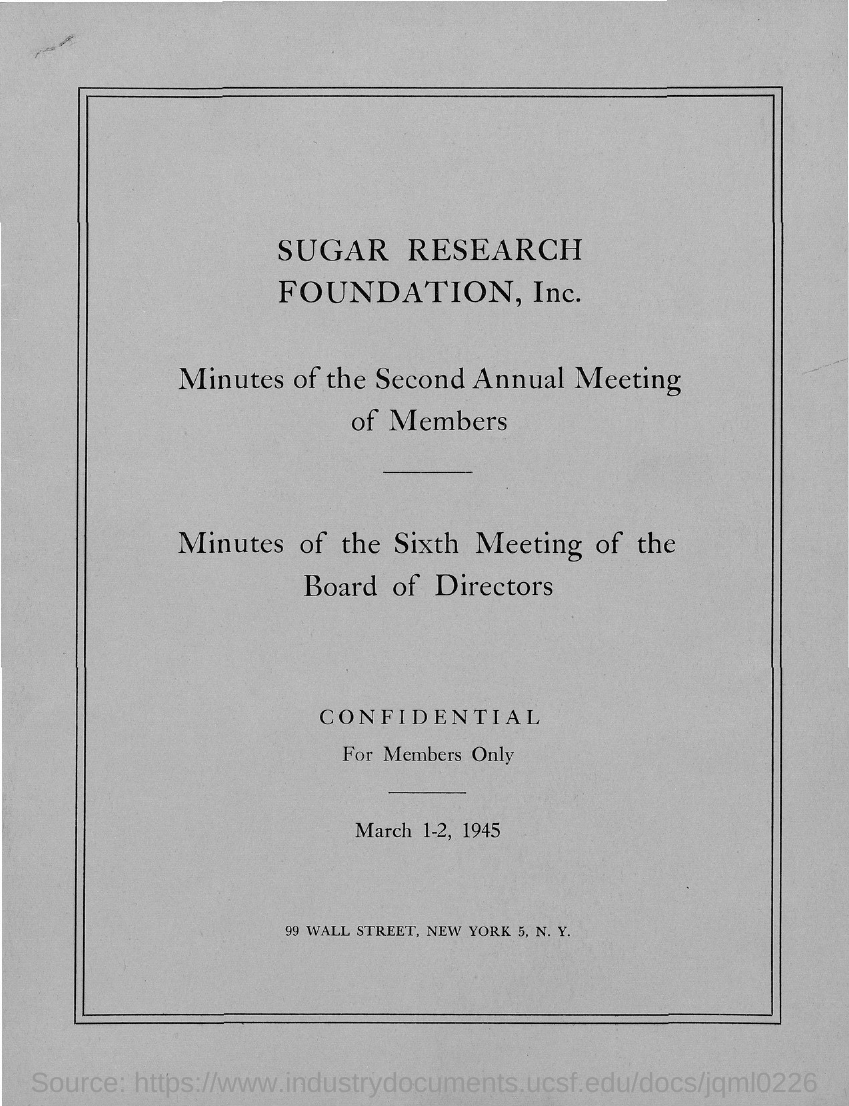Give some essential details in this illustration. The minutes of the meeting of SUGAR RESEARCH FOUNDATION, Inc. are mentioned. 